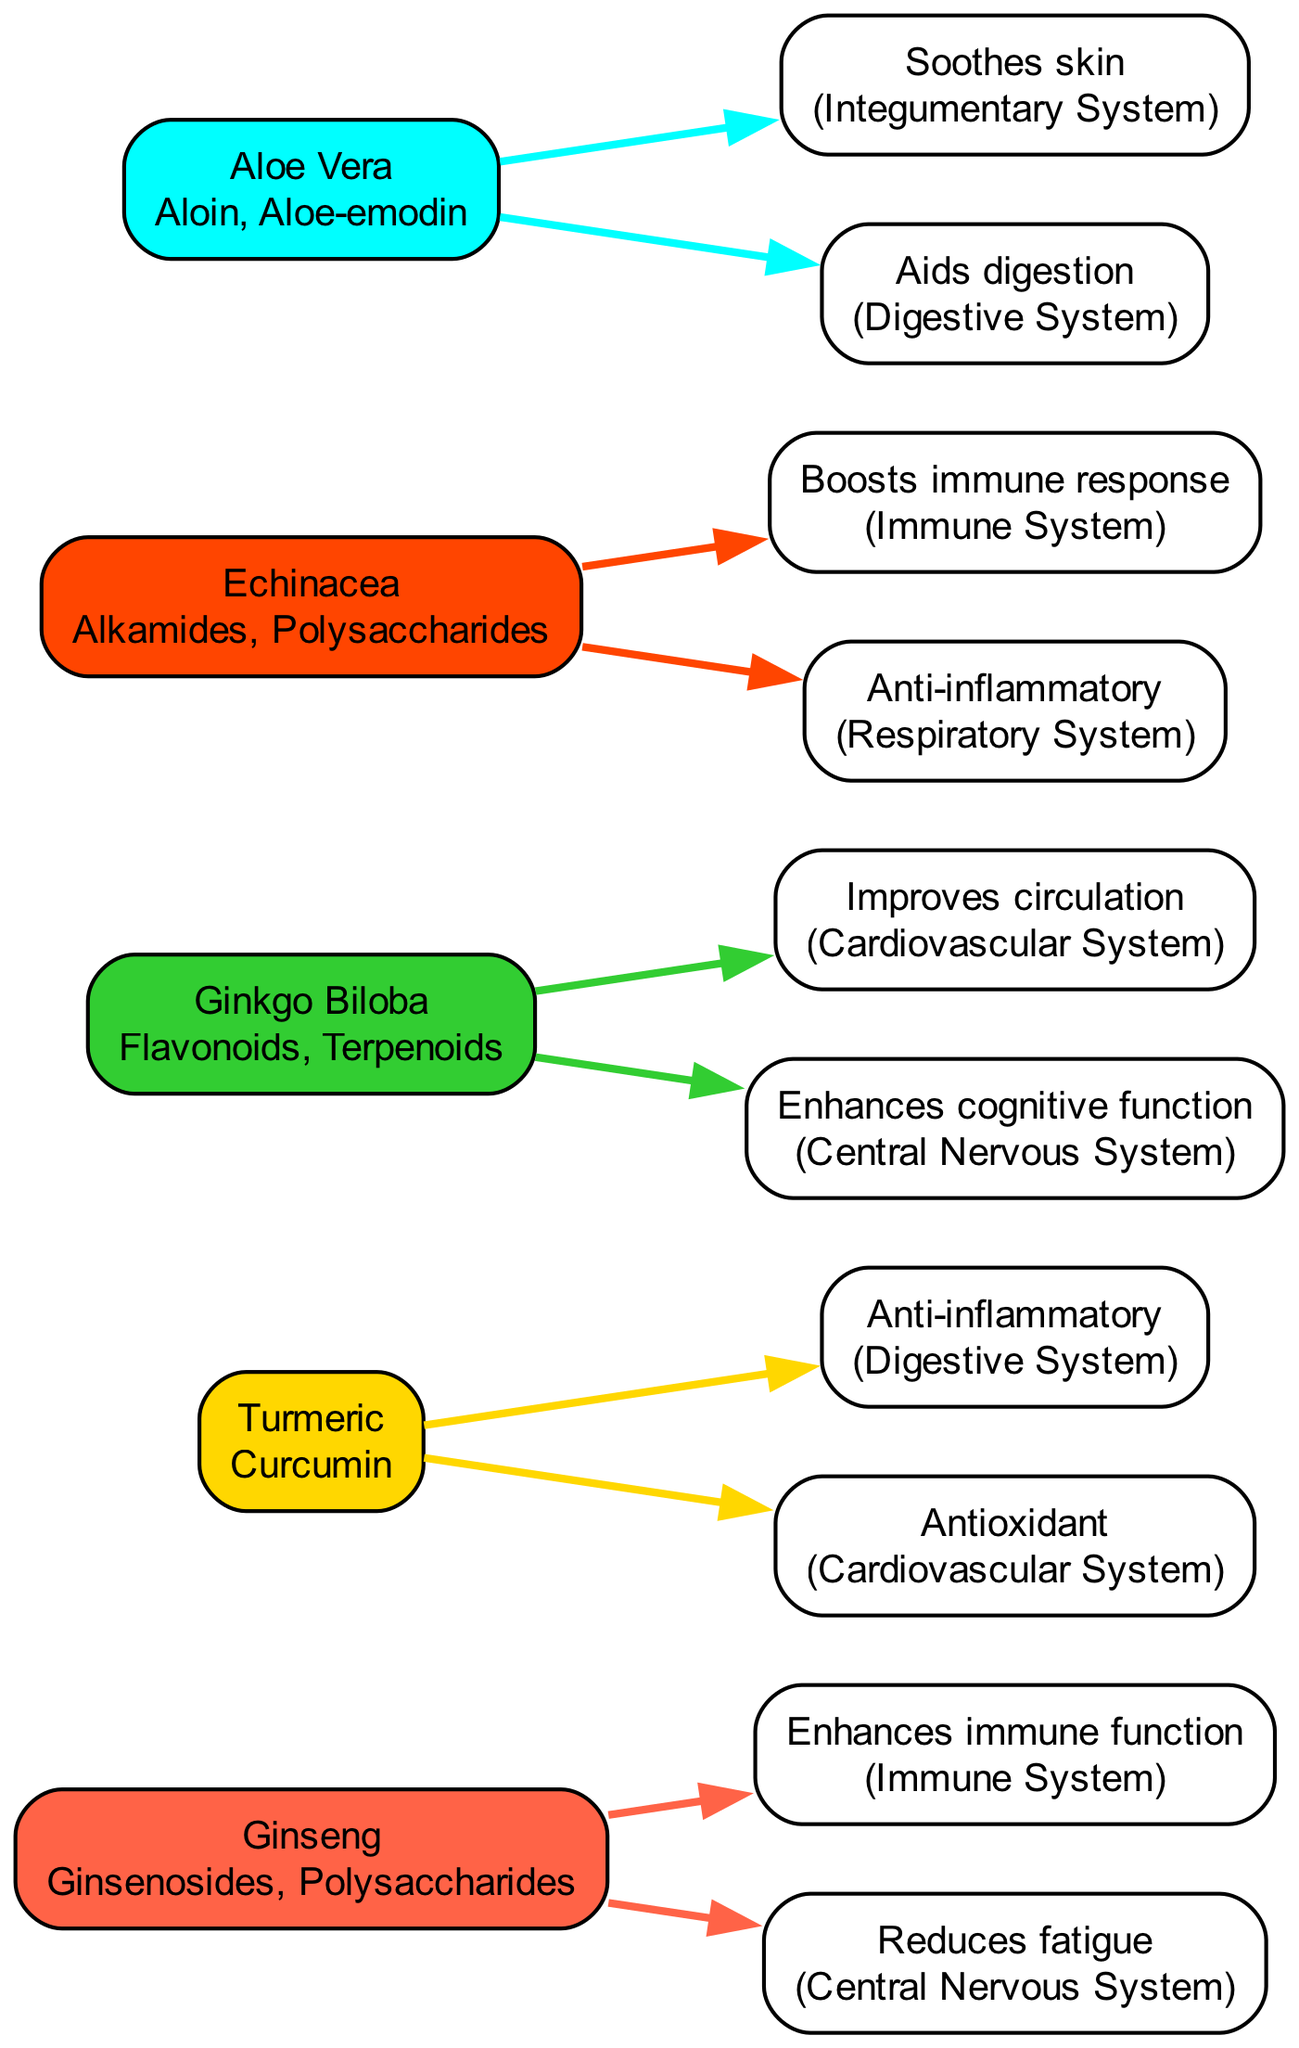What are the active compounds in Ginseng? The diagram lists "Ginsenosides" and "Polysaccharides" as the active compounds of Ginseng, which is directly noted within the herb's node.
Answer: Ginsenosides, Polysaccharides How many therapeutic effects are associated with Turmeric? By examining the node for Turmeric, two therapeutic effects are clearly indicated: "Anti-inflammatory" and "Antioxidant." Therefore, counting those gives a total of two effects.
Answer: 2 Which herb is linked to the Immune System? The diagram shows that both Ginseng and Echinacea are associated with the Immune System, as indicated by the edges connecting them to effects related to this system.
Answer: Ginseng, Echinacea What effect does Aloe Vera have on the Digestive System? The diagram lists "Aids digestion" under the therapeutic effects of Aloe Vera and connects it with the Digestive System. This indicates a direct therapeutic effect linked to this organ system.
Answer: Aids digestion Which herb improves circulation? Examining the therapeutic effects linked to the herbs, Ginkgo Biloba is specifically noted for "Improves circulation," which is connected through an edge to the Cardiovascular System.
Answer: Ginkgo Biloba What is the color code associated with Echinacea? The color code specific to Echinacea is shown in its node, which is noted as "#FF4500." This color corresponds to the visual representation of the herb in the diagram.
Answer: #FF4500 Which herb has a connection to both the Immune System and the Digestive System? By reviewing the therapeutic effects listed, Aloe Vera affects the Digestive System, while Echinacea affects the Immune System. No single herb connects to both, so the conclusion is that their effects lie in different systems.
Answer: None How many total herbs are represented in this diagram? The total number of herbs can be counted by reviewing the individual herb nodes. There are five distinct herbs represented in the diagram.
Answer: 5 Which active compound is unique to Echinacea? The active compounds listed for Echinacea include "Alkamides" and "Polysaccharides." Comparing these with other herbs shows that Alkamides is unique to Echinacea.
Answer: Alkamides 